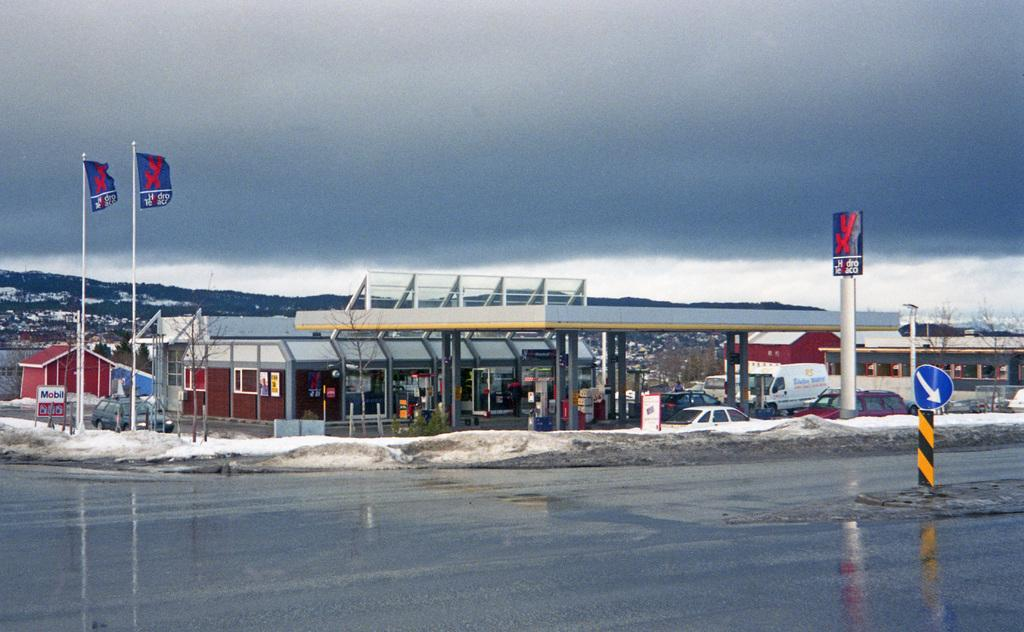What is the main feature in the front of the image? There is a glacier in the front of the image. What structure can be seen in the image? There is a building in the image. What are some objects near the building? Vehicles are present near the building. What decorative elements are in front of the building? There are flags in front of the building. What can be seen above the building and glacier? The sky is visible in the image, and clouds are present in the sky. What type of oven is being used to cook food in the image? There is no oven present in the image. How does the throat of the person in the image look? There is no person present in the image, so it is not possible to describe their throat. 